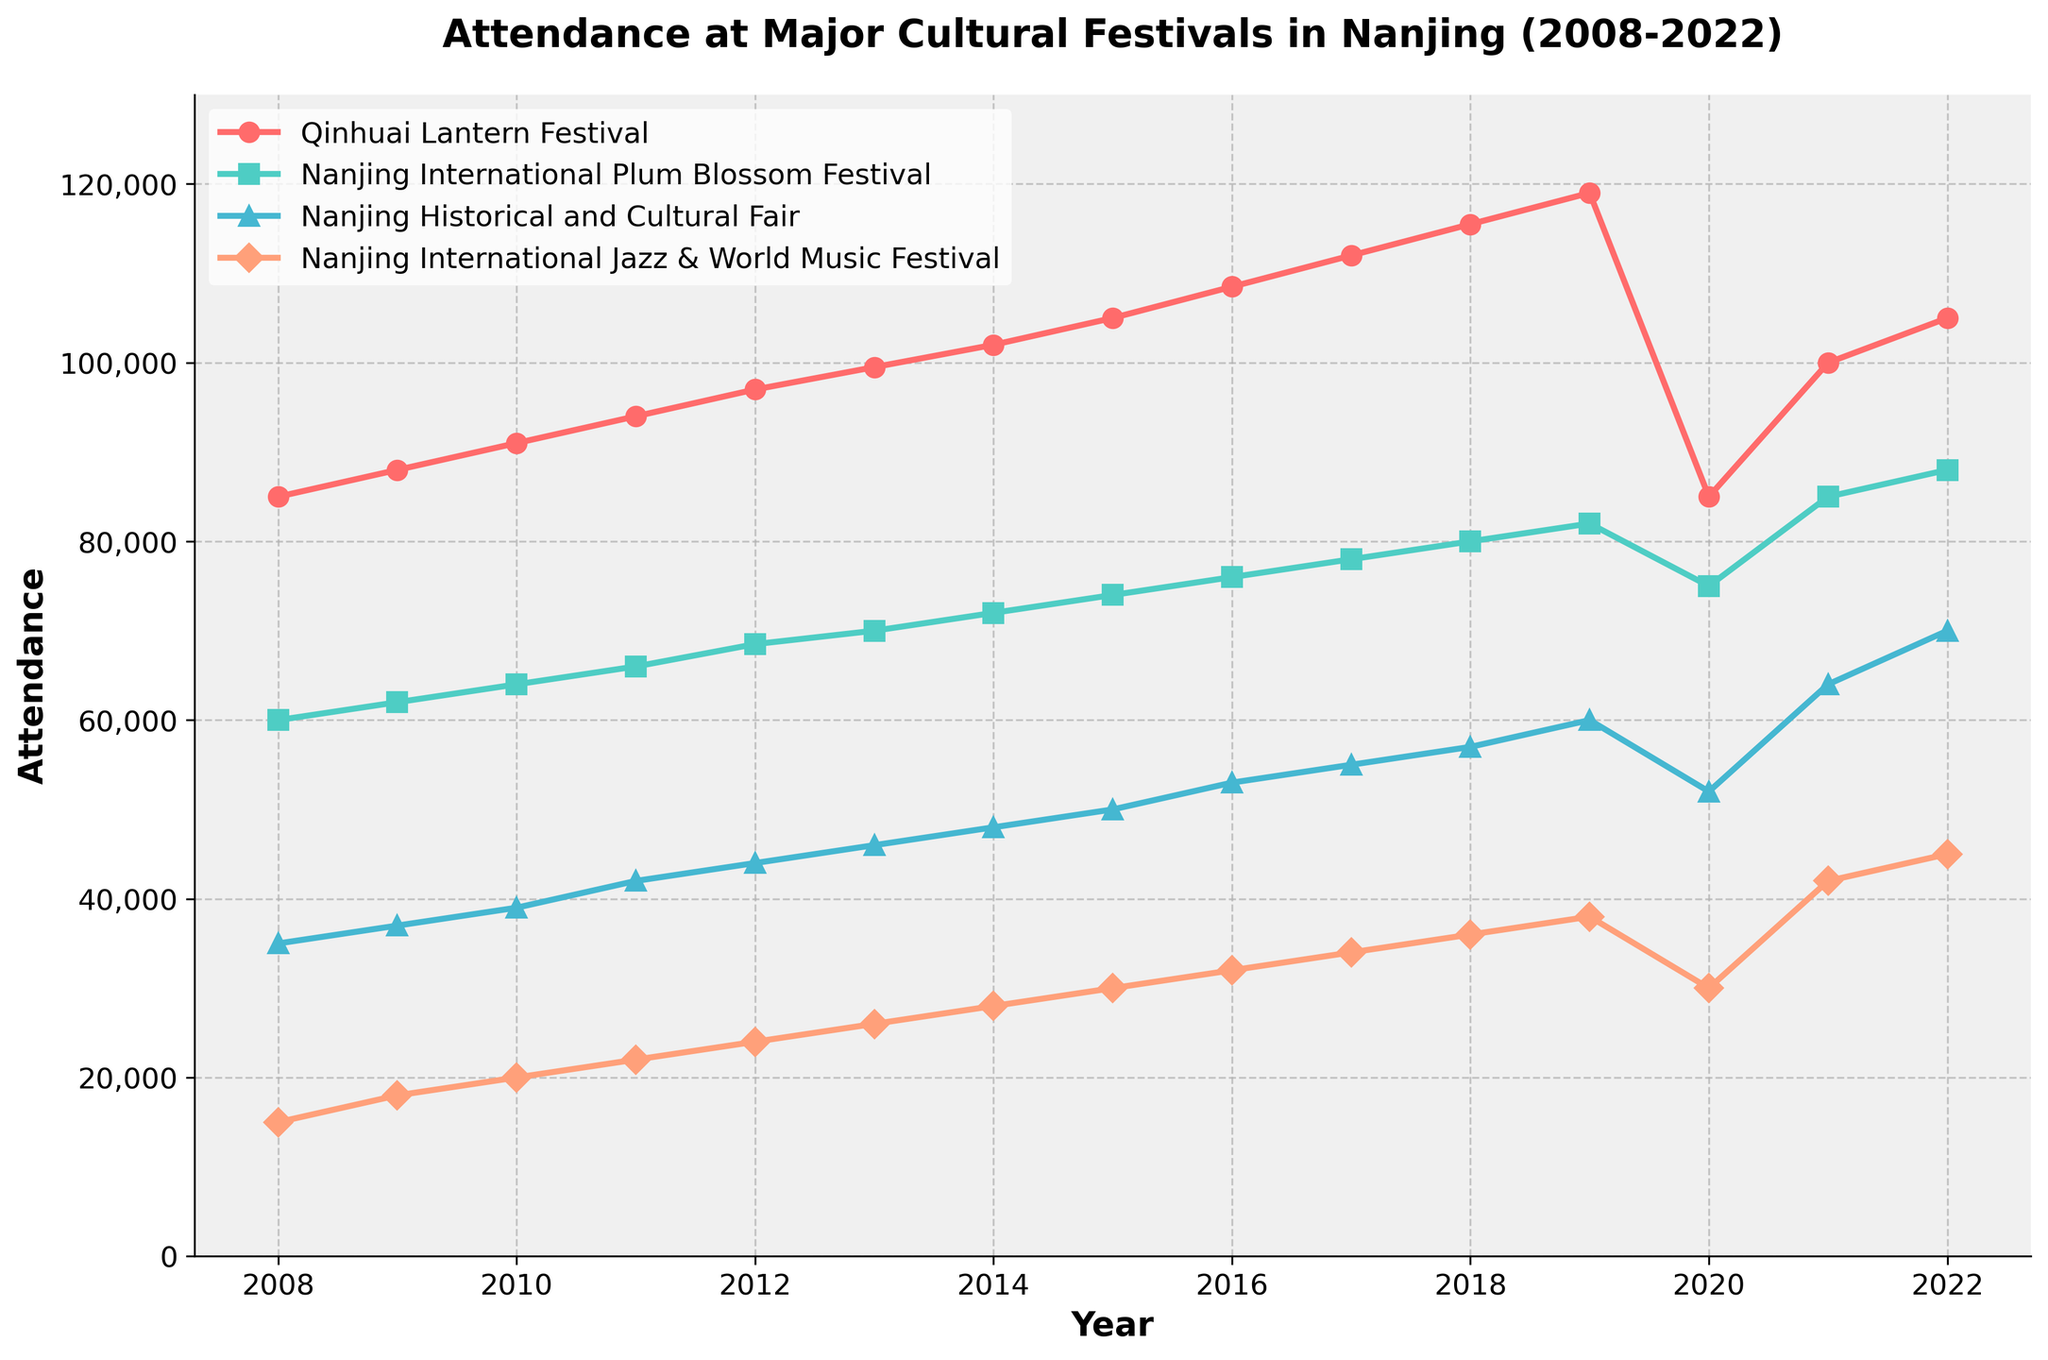What's the title of the figure? The title is displayed at the top of the figure, and it reads "Attendance at Major Cultural Festivals in Nanjing (2008-2022)".
Answer: Attendance at Major Cultural Festivals in Nanjing (2008-2022) How many data points are there for each festival? The x-axis ranges from 2008 to 2022, representing 15 data points for each festival.
Answer: 15 Which festival had the highest attendance in any single year, and what was the attendance? By looking at the peak values in the figure, the Qinhuai Lantern Festival had the highest attendance in 2019 with approximately 119,000 attendees.
Answer: Qinhuai Lantern Festival, 119,000 Which festival had the least attendance in 2020 and what was the attendance? Refer to the attendance values in 2020, the Nanjing Historical and Cultural Fair had the least attendance, marked by a value around 52,000.
Answer: Nanjing Historical and Cultural Fair, 52,000 What is the average attendance for the Nanjing International Jazz & World Music Festival from 2008 to 2022? Sum all the attendance values for Nanjing International Jazz & World Music Festival and divide by the number of data points (15). (15000+18000+20000+22000+24000+26000+28000+30000+32000+34000+36000+38000+30000+42000+45000)/15 = 29,667
Answer: 29,667 In what year was the attendance for Nanjing International Plum Blossom Festival higher than that of the Nanjing Historical and Cultural Fair, and by how much? The figure indicates that in years where the green line (Plum Blossom Festival) is higher than the orange line (Historical and Cultural Fair), the key year is 2021. In 2021, the Plum Blossom Festival had 85,000 attendees and the Historical and Cultural Fair had 64,000, resulting in a difference of 21,000.
Answer: 2021, 21,000 How has the attendance for the Qinhuai Lantern Festival changed from 2008 to 2022? The Qinhuai Lantern Festival attendance has increased steadily from 85,000 in 2008 to 119,000 in 2019. It dropped in 2020 back to 85,000 due to external factors, then increased again to 105,000 by 2022.
Answer: Increased, with a dip in 2020 Compare the trend between the Nanjing International Plum Blossom Festival and the Nanjing Historical and Cultural Fair from 2011 to 2022. From 2011 to 2022, both festivals show an upward trend in attendance. However, the Plum Blossom Festival increased more sharply compared to the Historical and Cultural Fair, especially post-2020.
Answer: Plum Blossom Festival increased more sharply Which festival showed the most significant drop in attendance between 2019 and 2020, and by how much? Examine the attendance for each festival in 2019 versus 2020. The Qinhuai Lantern Festival had the most significant drop from 119,000 in 2019 to 85,000 in 2020, a difference of 34,000.
Answer: Qinhuai Lantern Festival, 34,000 